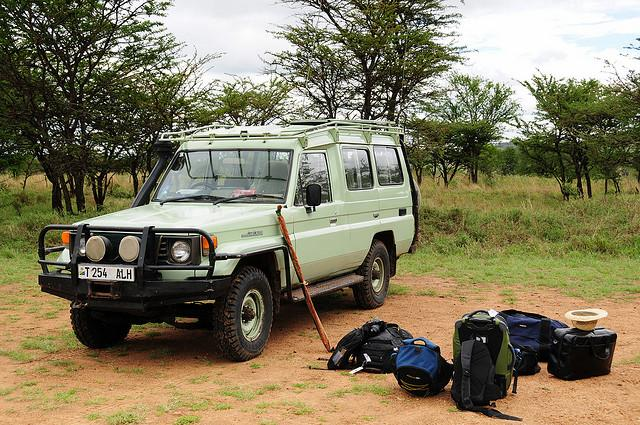What does the snorkel on the truck protect it from?

Choices:
A) fire
B) animals
C) dust
D) water water 